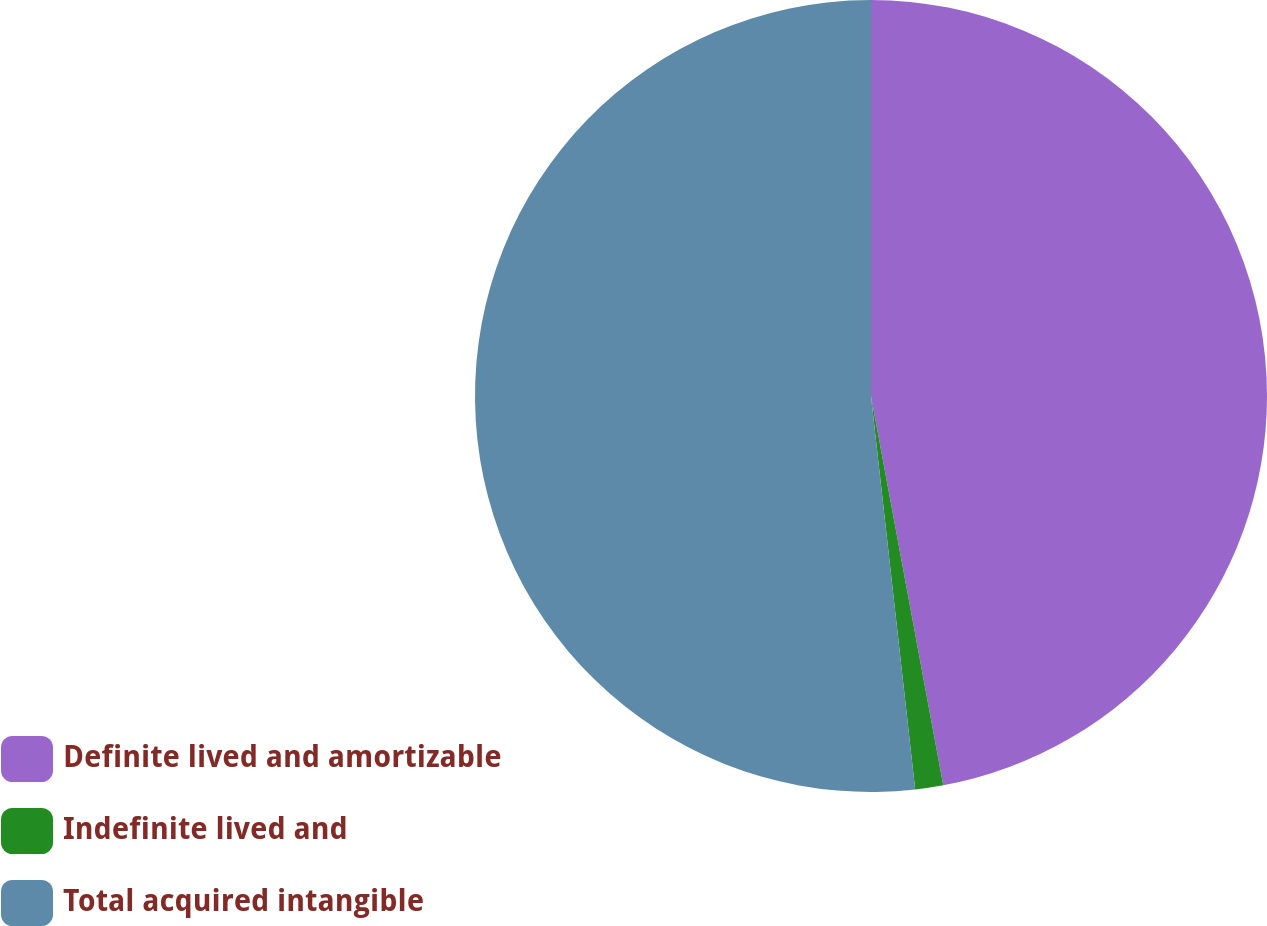Convert chart to OTSL. <chart><loc_0><loc_0><loc_500><loc_500><pie_chart><fcel>Definite lived and amortizable<fcel>Indefinite lived and<fcel>Total acquired intangible<nl><fcel>47.08%<fcel>1.14%<fcel>51.78%<nl></chart> 